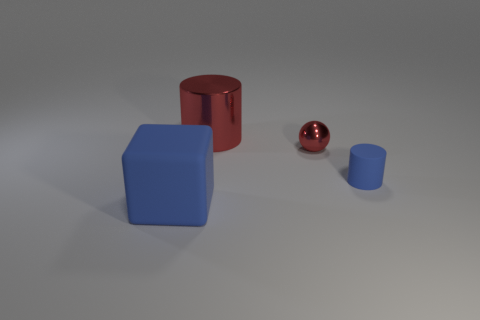Add 2 small blue matte cylinders. How many objects exist? 6 Subtract all cubes. How many objects are left? 3 Add 2 blue rubber cylinders. How many blue rubber cylinders are left? 3 Add 2 big gray metal cylinders. How many big gray metal cylinders exist? 2 Subtract 0 purple spheres. How many objects are left? 4 Subtract all big red matte cylinders. Subtract all small cylinders. How many objects are left? 3 